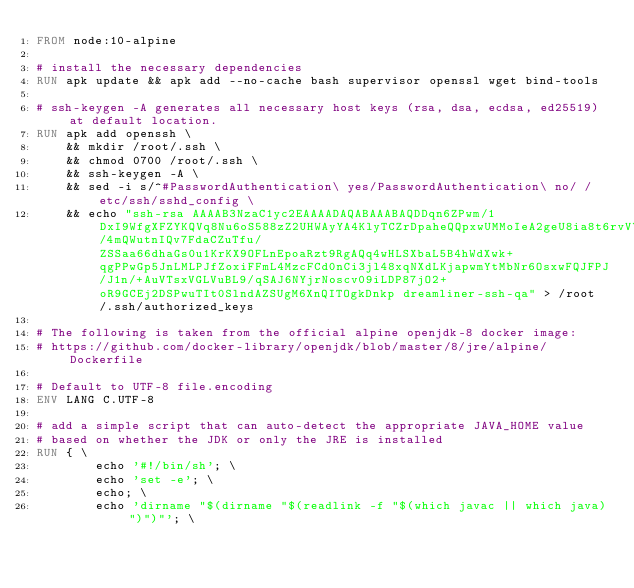<code> <loc_0><loc_0><loc_500><loc_500><_Dockerfile_>FROM node:10-alpine

# install the necessary dependencies
RUN apk update && apk add --no-cache bash supervisor openssl wget bind-tools

# ssh-keygen -A generates all necessary host keys (rsa, dsa, ecdsa, ed25519) at default location.
RUN apk add openssh \
    && mkdir /root/.ssh \
    && chmod 0700 /root/.ssh \
    && ssh-keygen -A \
    && sed -i s/^#PasswordAuthentication\ yes/PasswordAuthentication\ no/ /etc/ssh/sshd_config \
    && echo "ssh-rsa AAAAB3NzaC1yc2EAAAADAQABAAABAQDDqn6ZPwm/1DxI9WfgXFZYKQVq8Nu6oS588zZ2UHWAyYA4KlyTCZrDpaheQQpxwUMMoIeA2geU8ia8t6rvVYUl9sE2UJlvhwRFqv8c4tw62Q/4mQWutnIQv7FdaCZuTfu/ZSSaa66dhaGs0u1KrKX9OFLnEpoaRzt9RgAQq4wHLSXbaL5B4hWdXwk+qgPPwGp5JnLMLPJfZoxiFFmL4MzcFCd0nCi3jl48xqNXdLKjapwmYtMbNr6OsxwFQJFPJ/J1n/+AuVTsxVGLVuBL9/qSAJ6NYjrNoscv09iLDP87jO2+oR9GCEj2DSPwuTIt0SlndAZSUgM6XnQITOgkDnkp dreamliner-ssh-qa" > /root/.ssh/authorized_keys

# The following is taken from the official alpine openjdk-8 docker image:
# https://github.com/docker-library/openjdk/blob/master/8/jre/alpine/Dockerfile

# Default to UTF-8 file.encoding
ENV LANG C.UTF-8

# add a simple script that can auto-detect the appropriate JAVA_HOME value
# based on whether the JDK or only the JRE is installed
RUN { \
		echo '#!/bin/sh'; \
		echo 'set -e'; \
		echo; \
		echo 'dirname "$(dirname "$(readlink -f "$(which javac || which java)")")"'; \</code> 